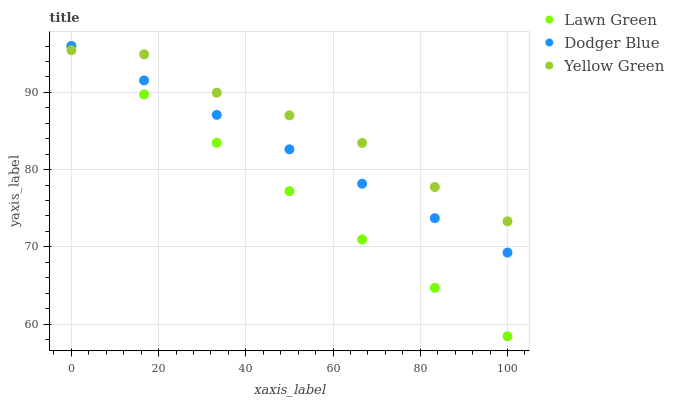Does Lawn Green have the minimum area under the curve?
Answer yes or no. Yes. Does Yellow Green have the maximum area under the curve?
Answer yes or no. Yes. Does Dodger Blue have the minimum area under the curve?
Answer yes or no. No. Does Dodger Blue have the maximum area under the curve?
Answer yes or no. No. Is Lawn Green the smoothest?
Answer yes or no. Yes. Is Yellow Green the roughest?
Answer yes or no. Yes. Is Dodger Blue the smoothest?
Answer yes or no. No. Is Dodger Blue the roughest?
Answer yes or no. No. Does Lawn Green have the lowest value?
Answer yes or no. Yes. Does Dodger Blue have the lowest value?
Answer yes or no. No. Does Dodger Blue have the highest value?
Answer yes or no. Yes. Does Yellow Green have the highest value?
Answer yes or no. No. Does Yellow Green intersect Lawn Green?
Answer yes or no. Yes. Is Yellow Green less than Lawn Green?
Answer yes or no. No. Is Yellow Green greater than Lawn Green?
Answer yes or no. No. 